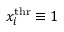Convert formula to latex. <formula><loc_0><loc_0><loc_500><loc_500>x _ { i } ^ { t h r } \equiv 1</formula> 